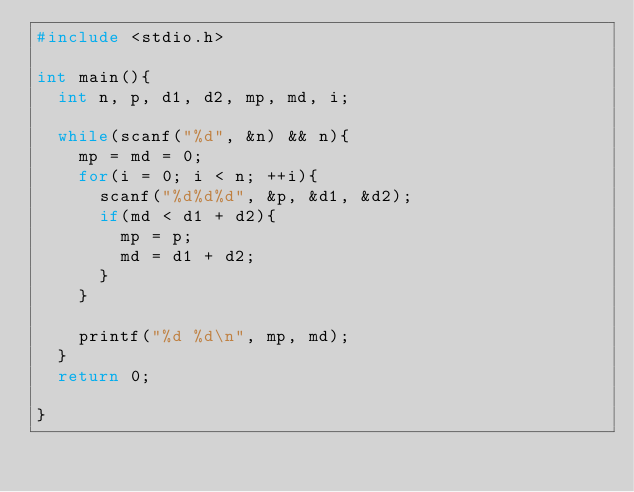<code> <loc_0><loc_0><loc_500><loc_500><_C_>#include <stdio.h>

int main(){
  int n, p, d1, d2, mp, md, i;

  while(scanf("%d", &n) && n){
    mp = md = 0;
    for(i = 0; i < n; ++i){
      scanf("%d%d%d", &p, &d1, &d2);
      if(md < d1 + d2){
        mp = p;
        md = d1 + d2;
      }
    }

    printf("%d %d\n", mp, md);
  }
  return 0;

}</code> 